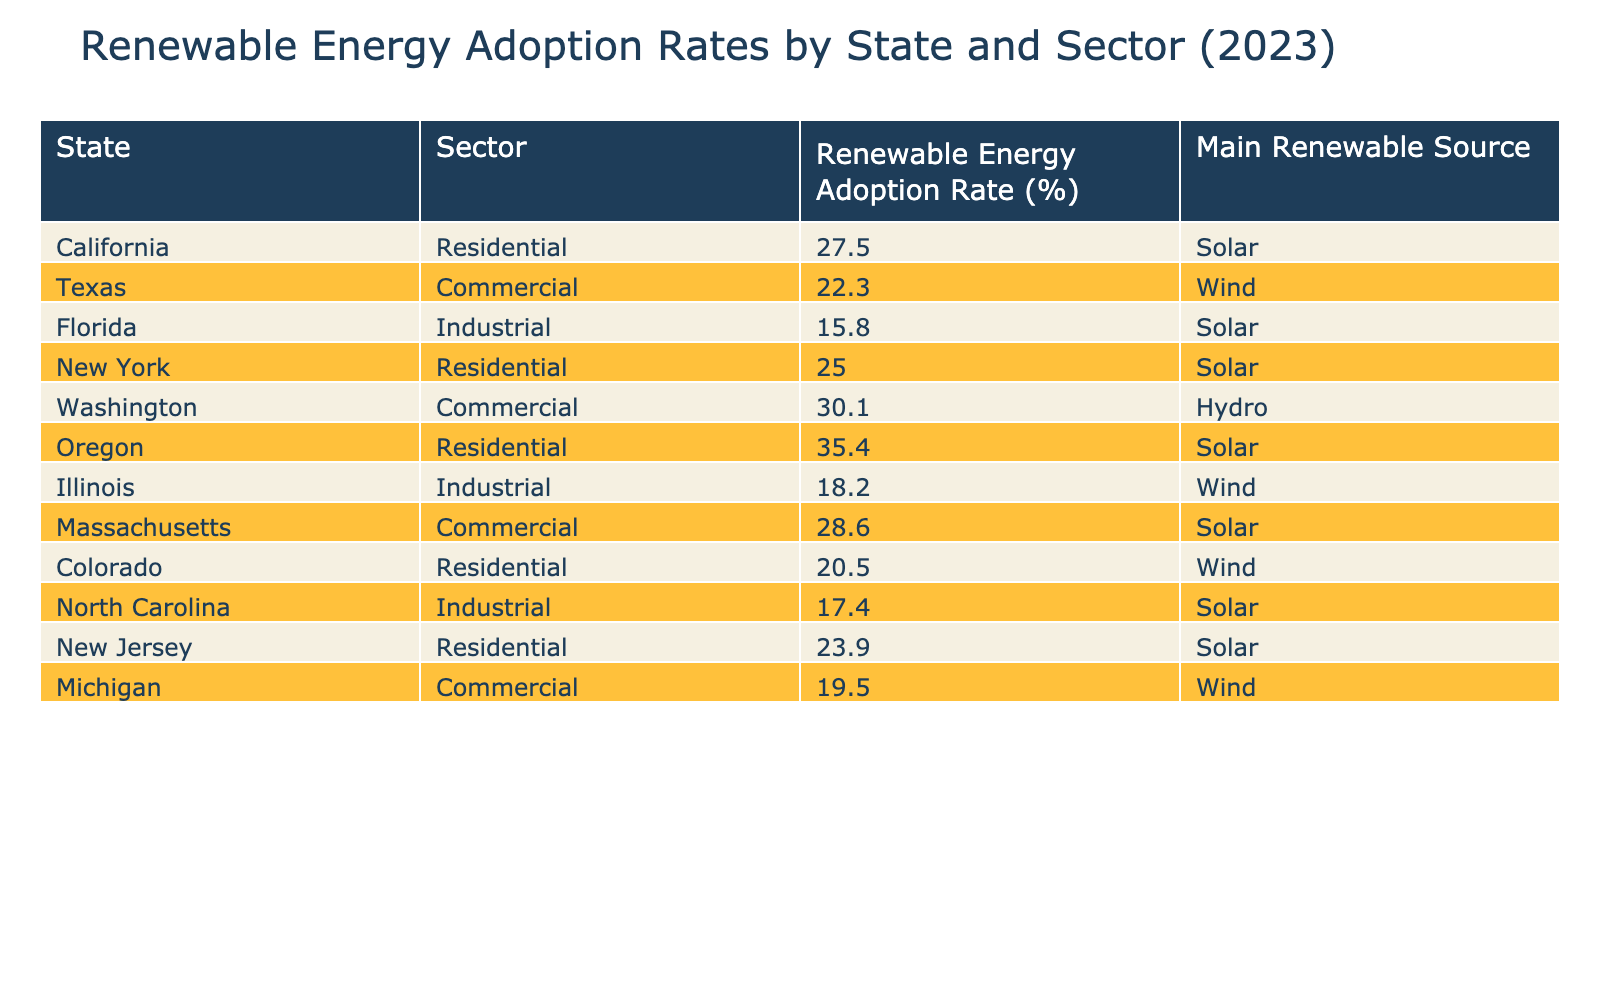What is the highest renewable energy adoption rate and which state does it belong to? The highest renewable energy adoption rate in the table is 35.4%, and it belongs to Oregon in the Residential sector.
Answer: 35.4% (Oregon) Which state has the lowest adoption rate in the industrial sector? In the industrial sector, North Carolina has the lowest adoption rate at 17.4%.
Answer: 17.4% (North Carolina) What is the average renewable energy adoption rate for the residential sector based on the data? To find the average for the residential sector, we sum the adoption rates of California (27.5%), New York (25.0%), Oregon (35.4%), Colorado (20.5%), and New Jersey (23.9%). This gives us a total of 27.5 + 25.0 + 35.4 + 20.5 + 23.9 = 132.3%. Dividing this by the 5 states gives an average of 132.3/5 = 26.46%.
Answer: 26.46% Is Florida a leader in renewable energy adoption for the industrial sector? No, Florida's adoption rate of 15.8% is lower than many other states in the industrial sector, specifically North Carolina, which has a higher rate of 17.4%.
Answer: No How many states have a commercial sector adoption rate of over 25%? Checking the commercial sector values, we find Washington (30.1%) and Massachusetts (28.6%), which means there are 2 states with over 25% adoption.
Answer: 2 states 